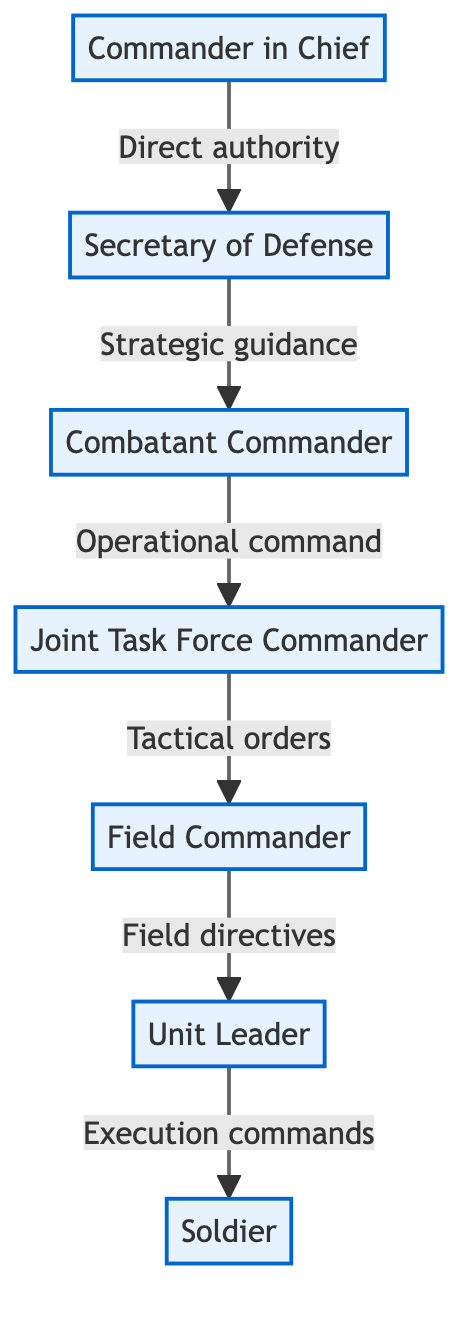What is the topmost position in the military chain of command? The diagram clearly shows that the topmost position is the "Commander in Chief," as it is the first node and no nodes are positioned above it in the flow.
Answer: Commander in Chief How many nodes are in the diagram? By counting each distinct position displayed in the diagram, there are a total of 7 nodes, which represent the different ranks in the military command chain.
Answer: 7 Who does the Secretary of Defense provide strategic guidance to? The diagram indicates that the Secretary of Defense (second node) provides strategic guidance to the "Combatant Commander," as it is linked directly with that relationship.
Answer: Combatant Commander What type of orders does the Joint Task Force Commander issue? The Joint Task Force Commander (fourth node) is connected to the Field Commander with the label "Tactical orders," which specifies the kind of orders that are issued in that relationship.
Answer: Tactical orders What is the relationship between the Combatant Commander and the Field Commander? Analyzing the links in the diagram shows that the Combatant Commander gives "Operational command" to the Joint Task Force Commander, who subsequently gives "Tactical orders" to the Field Commander. Thus, the relationship is a chain of command where operational commands lead to tactical orders.
Answer: Operational command to Tactical orders How many levels of command are below the Commander in Chief? The diagram depicts a descending chain starting from the Commander in Chief, and goes down five levels: Secretary of Defense, Combatant Commander, Joint Task Force Commander, Field Commander, and Unit Leader. Thus, there are five levels.
Answer: 5 Who is responsible for execution commands? The diagram indicates that the "Soldier" is issued "Execution commands" by the Unit Leader, making the Soldier the one directly responsible for executing orders.
Answer: Soldier What type of directives does the Field Commander provide? In the diagram, it is clear that the Field Commander gives "Field directives" as the term is specifically mentioned next to the connection to the Unit Leader.
Answer: Field directives What is the flow of commands from the Secretary of Defense to the Soldier? Starting from the Secretary of Defense, the flow of commands progresses as follows: Secretary of Defense gives strategic guidance to Combatant Commander, who gives operational command to Joint Task Force Commander, who gives tactical orders to Field Commander, who gives field directives to Unit Leader, who executes commands to Soldier. This sequential relationship defines the entire command flow to the Soldier.
Answer: Strategic guidance to Execution commands 